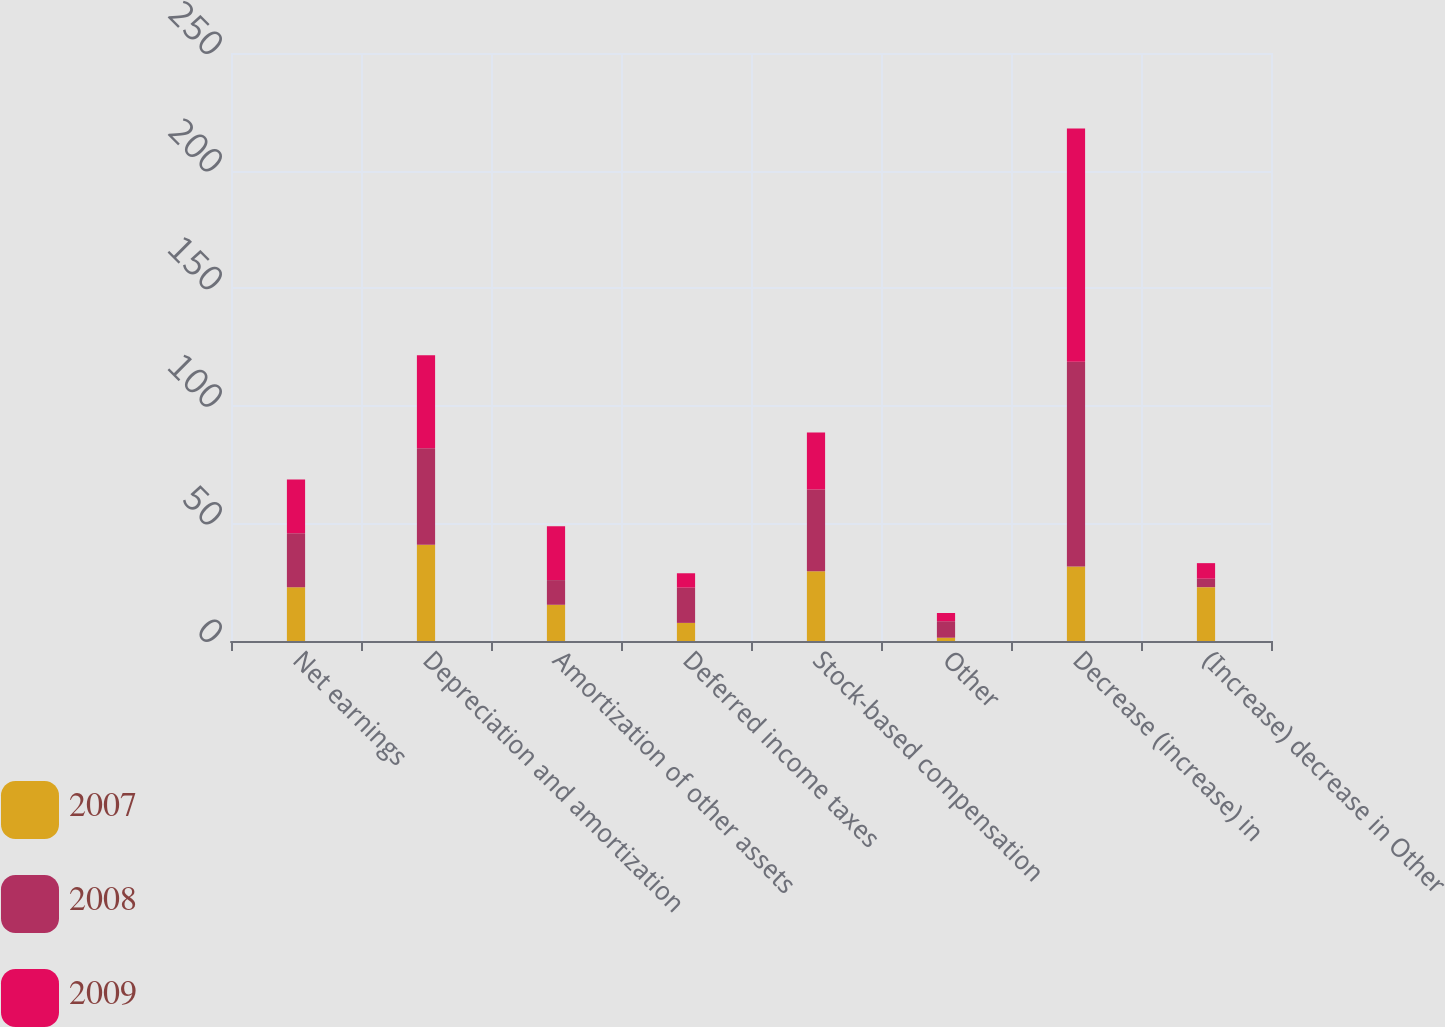<chart> <loc_0><loc_0><loc_500><loc_500><stacked_bar_chart><ecel><fcel>Net earnings<fcel>Depreciation and amortization<fcel>Amortization of other assets<fcel>Deferred income taxes<fcel>Stock-based compensation<fcel>Other<fcel>Decrease (increase) in<fcel>(Increase) decrease in Other<nl><fcel>2007<fcel>22.9<fcel>40.9<fcel>15.4<fcel>7.7<fcel>29.7<fcel>1.4<fcel>31.7<fcel>22.9<nl><fcel>2008<fcel>22.9<fcel>41<fcel>10.5<fcel>15<fcel>34.7<fcel>7<fcel>87<fcel>3.6<nl><fcel>2009<fcel>22.9<fcel>39.6<fcel>22.9<fcel>6.1<fcel>24.3<fcel>3.5<fcel>99.2<fcel>6.6<nl></chart> 